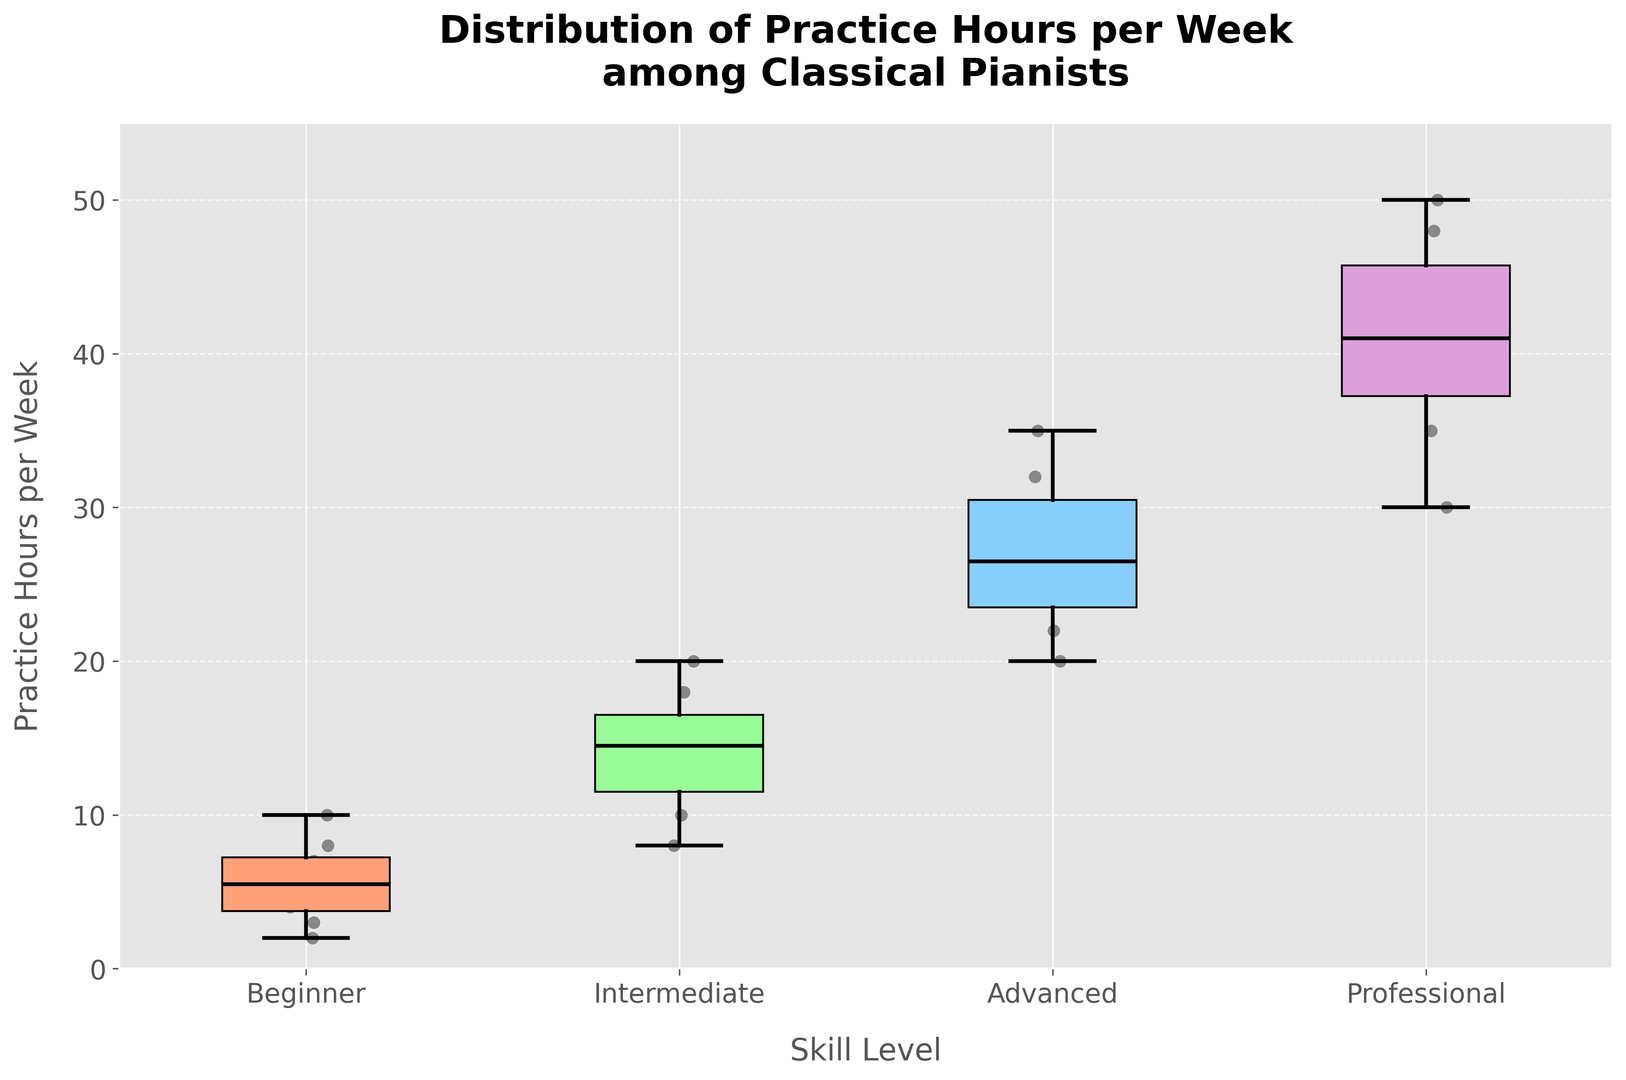What is the median practice hours per week for intermediate pianists? The median practice hours for the intermediate group can be identified by finding the line inside the box which represents the median value. It's positioned around 15 hours.
Answer: 15 Which skill level shows the most variability in practice hours? Variability can be interpreted by looking at the length of the box and the whiskers. The "Professional" level shows the most variability as it has the longest box and whiskers.
Answer: Professional How do the median practice hours compare between beginners and advanced pianists? The median for beginners is around 6 hours while for advanced pianists, it's around 26 hours, indicating that advanced pianists practice significantly more than beginners.
Answer: Advanced > Beginner What is the interquartile range (IQR) for beginner pianists? The interquartile range is the length of the box in the box plot. For beginners, it extends from 3 hours (Q1) to 8 hours (Q3), so IQR is 8 - 3 = 5 hours.
Answer: 5 Which skill level has the highest median practice hours? The highest median is indicated by the line inside the box plot that’s highest on the y-axis. "Professional" has the highest median practice hours.
Answer: Professional Are there any outliers in the professional skill level’s practice hours? Outliers are typically indicated by dots outside the whiskers. The professional level shows no such dots, indicating no outliers.
Answer: No How do the practice times differ between beginners and professionals in terms of range? The range can be calculated by subtracting the minimum whisker value from the maximum whisker value. For beginners: 10 - 2 = 8 hours, for professionals: 50 - 30 = 20 hours, showing professionals have a wider range.
Answer: Professionals > Beginners What color is used to represent intermediate pianists in the box plot? The color is noted visually from the plot. The boxes for intermediate pianists are colored in light green.
Answer: Light Green 